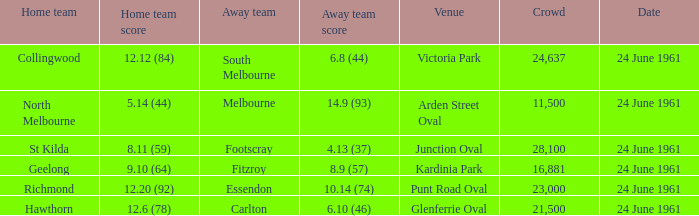What was the average crowd size of games held at Glenferrie Oval? 21500.0. 